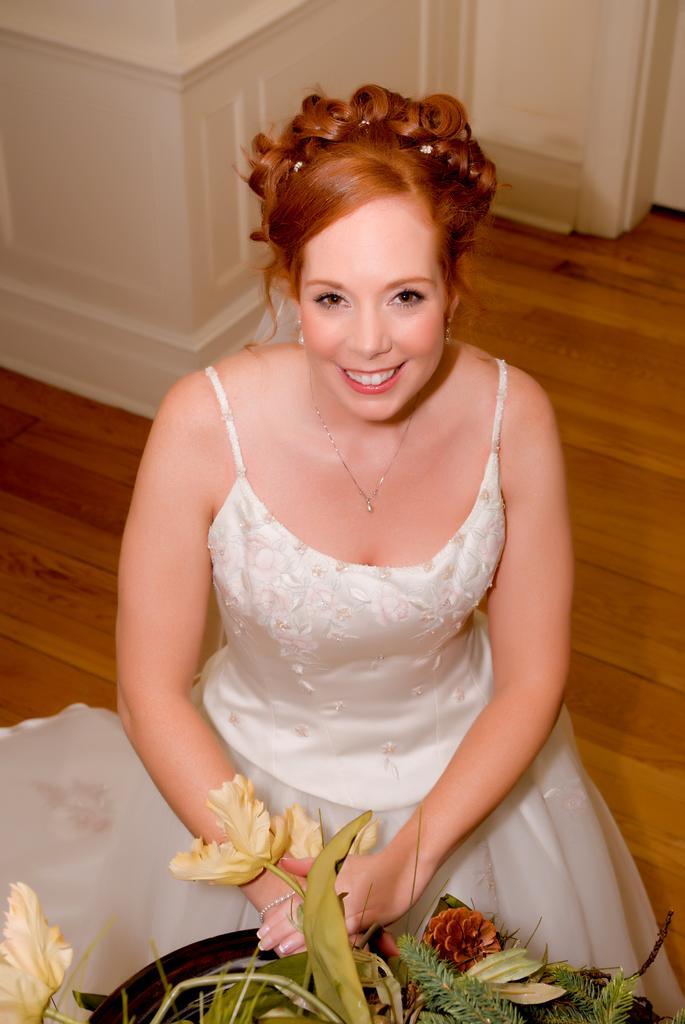Could you give a brief overview of what you see in this image? In this image we can see a woman sitting on the floor. We can also see a plant with a pot front of her. 